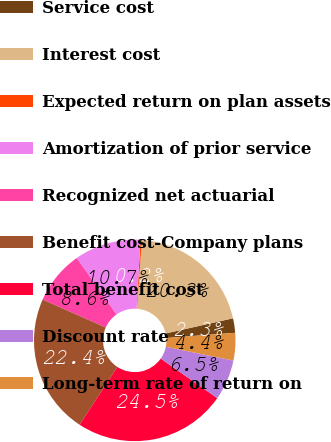Convert chart to OTSL. <chart><loc_0><loc_0><loc_500><loc_500><pie_chart><fcel>Service cost<fcel>Interest cost<fcel>Expected return on plan assets<fcel>Amortization of prior service<fcel>Recognized net actuarial<fcel>Benefit cost-Company plans<fcel>Total benefit cost<fcel>Discount rate<fcel>Long-term rate of return on<nl><fcel>2.32%<fcel>20.34%<fcel>0.23%<fcel>10.67%<fcel>8.59%<fcel>22.42%<fcel>24.51%<fcel>6.5%<fcel>4.41%<nl></chart> 